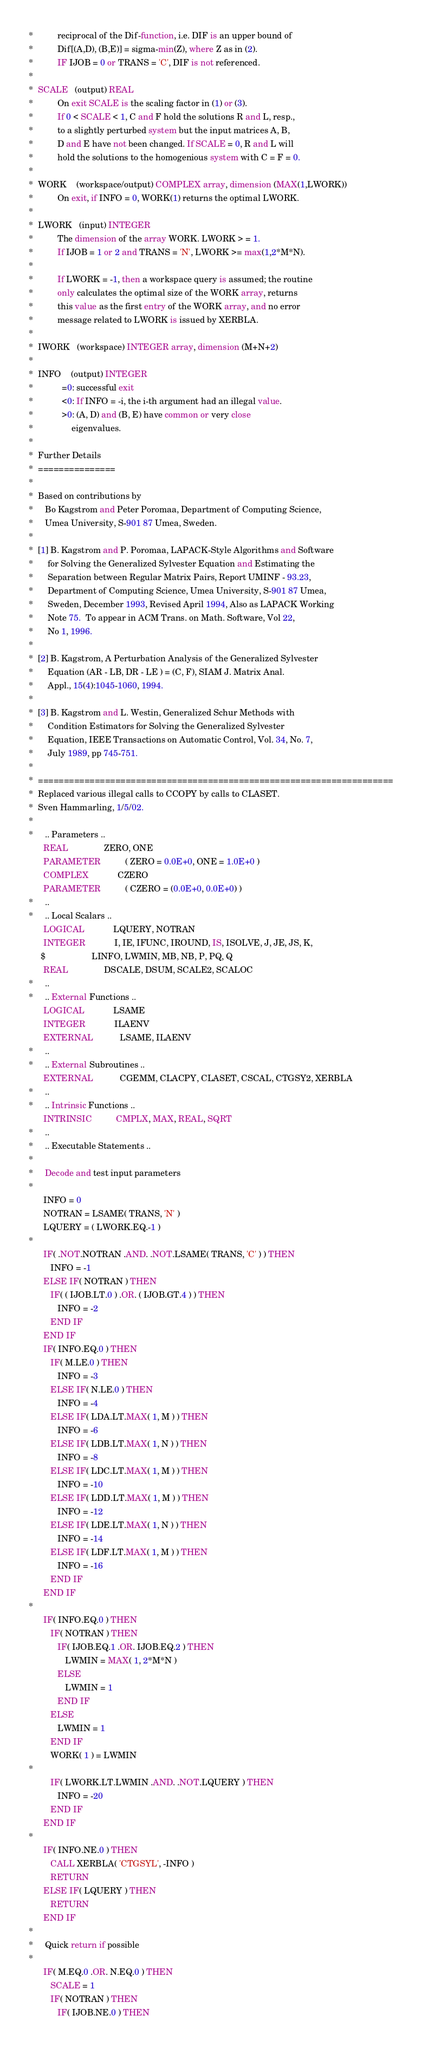Convert code to text. <code><loc_0><loc_0><loc_500><loc_500><_FORTRAN_>*          reciprocal of the Dif-function, i.e. DIF is an upper bound of
*          Dif[(A,D), (B,E)] = sigma-min(Z), where Z as in (2).
*          IF IJOB = 0 or TRANS = 'C', DIF is not referenced.
*
*  SCALE   (output) REAL
*          On exit SCALE is the scaling factor in (1) or (3).
*          If 0 < SCALE < 1, C and F hold the solutions R and L, resp.,
*          to a slightly perturbed system but the input matrices A, B,
*          D and E have not been changed. If SCALE = 0, R and L will
*          hold the solutions to the homogenious system with C = F = 0.
*
*  WORK    (workspace/output) COMPLEX array, dimension (MAX(1,LWORK))
*          On exit, if INFO = 0, WORK(1) returns the optimal LWORK.
*
*  LWORK   (input) INTEGER
*          The dimension of the array WORK. LWORK > = 1.
*          If IJOB = 1 or 2 and TRANS = 'N', LWORK >= max(1,2*M*N).
*
*          If LWORK = -1, then a workspace query is assumed; the routine
*          only calculates the optimal size of the WORK array, returns
*          this value as the first entry of the WORK array, and no error
*          message related to LWORK is issued by XERBLA.
*
*  IWORK   (workspace) INTEGER array, dimension (M+N+2)
*
*  INFO    (output) INTEGER
*            =0: successful exit
*            <0: If INFO = -i, the i-th argument had an illegal value.
*            >0: (A, D) and (B, E) have common or very close
*                eigenvalues.
*
*  Further Details
*  ===============
*
*  Based on contributions by
*     Bo Kagstrom and Peter Poromaa, Department of Computing Science,
*     Umea University, S-901 87 Umea, Sweden.
*
*  [1] B. Kagstrom and P. Poromaa, LAPACK-Style Algorithms and Software
*      for Solving the Generalized Sylvester Equation and Estimating the
*      Separation between Regular Matrix Pairs, Report UMINF - 93.23,
*      Department of Computing Science, Umea University, S-901 87 Umea,
*      Sweden, December 1993, Revised April 1994, Also as LAPACK Working
*      Note 75.  To appear in ACM Trans. on Math. Software, Vol 22,
*      No 1, 1996.
*
*  [2] B. Kagstrom, A Perturbation Analysis of the Generalized Sylvester
*      Equation (AR - LB, DR - LE ) = (C, F), SIAM J. Matrix Anal.
*      Appl., 15(4):1045-1060, 1994.
*
*  [3] B. Kagstrom and L. Westin, Generalized Schur Methods with
*      Condition Estimators for Solving the Generalized Sylvester
*      Equation, IEEE Transactions on Automatic Control, Vol. 34, No. 7,
*      July 1989, pp 745-751.
*
*  =====================================================================
*  Replaced various illegal calls to CCOPY by calls to CLASET.
*  Sven Hammarling, 1/5/02.
*
*     .. Parameters ..
      REAL               ZERO, ONE
      PARAMETER          ( ZERO = 0.0E+0, ONE = 1.0E+0 )
      COMPLEX            CZERO
      PARAMETER          ( CZERO = (0.0E+0, 0.0E+0) )
*     ..
*     .. Local Scalars ..
      LOGICAL            LQUERY, NOTRAN
      INTEGER            I, IE, IFUNC, IROUND, IS, ISOLVE, J, JE, JS, K,
     $                   LINFO, LWMIN, MB, NB, P, PQ, Q
      REAL               DSCALE, DSUM, SCALE2, SCALOC
*     ..
*     .. External Functions ..
      LOGICAL            LSAME
      INTEGER            ILAENV
      EXTERNAL           LSAME, ILAENV
*     ..
*     .. External Subroutines ..
      EXTERNAL           CGEMM, CLACPY, CLASET, CSCAL, CTGSY2, XERBLA
*     ..
*     .. Intrinsic Functions ..
      INTRINSIC          CMPLX, MAX, REAL, SQRT
*     ..
*     .. Executable Statements ..
*
*     Decode and test input parameters
*
      INFO = 0
      NOTRAN = LSAME( TRANS, 'N' )
      LQUERY = ( LWORK.EQ.-1 )
*
      IF( .NOT.NOTRAN .AND. .NOT.LSAME( TRANS, 'C' ) ) THEN
         INFO = -1
      ELSE IF( NOTRAN ) THEN
         IF( ( IJOB.LT.0 ) .OR. ( IJOB.GT.4 ) ) THEN
            INFO = -2
         END IF
      END IF
      IF( INFO.EQ.0 ) THEN
         IF( M.LE.0 ) THEN
            INFO = -3
         ELSE IF( N.LE.0 ) THEN
            INFO = -4
         ELSE IF( LDA.LT.MAX( 1, M ) ) THEN
            INFO = -6
         ELSE IF( LDB.LT.MAX( 1, N ) ) THEN
            INFO = -8
         ELSE IF( LDC.LT.MAX( 1, M ) ) THEN
            INFO = -10
         ELSE IF( LDD.LT.MAX( 1, M ) ) THEN
            INFO = -12
         ELSE IF( LDE.LT.MAX( 1, N ) ) THEN
            INFO = -14
         ELSE IF( LDF.LT.MAX( 1, M ) ) THEN
            INFO = -16
         END IF
      END IF
*
      IF( INFO.EQ.0 ) THEN
         IF( NOTRAN ) THEN
            IF( IJOB.EQ.1 .OR. IJOB.EQ.2 ) THEN
               LWMIN = MAX( 1, 2*M*N )
            ELSE
               LWMIN = 1
            END IF
         ELSE
            LWMIN = 1
         END IF
         WORK( 1 ) = LWMIN
*
         IF( LWORK.LT.LWMIN .AND. .NOT.LQUERY ) THEN
            INFO = -20
         END IF
      END IF
*
      IF( INFO.NE.0 ) THEN
         CALL XERBLA( 'CTGSYL', -INFO )
         RETURN
      ELSE IF( LQUERY ) THEN
         RETURN
      END IF
*
*     Quick return if possible
*
      IF( M.EQ.0 .OR. N.EQ.0 ) THEN
         SCALE = 1
         IF( NOTRAN ) THEN
            IF( IJOB.NE.0 ) THEN</code> 